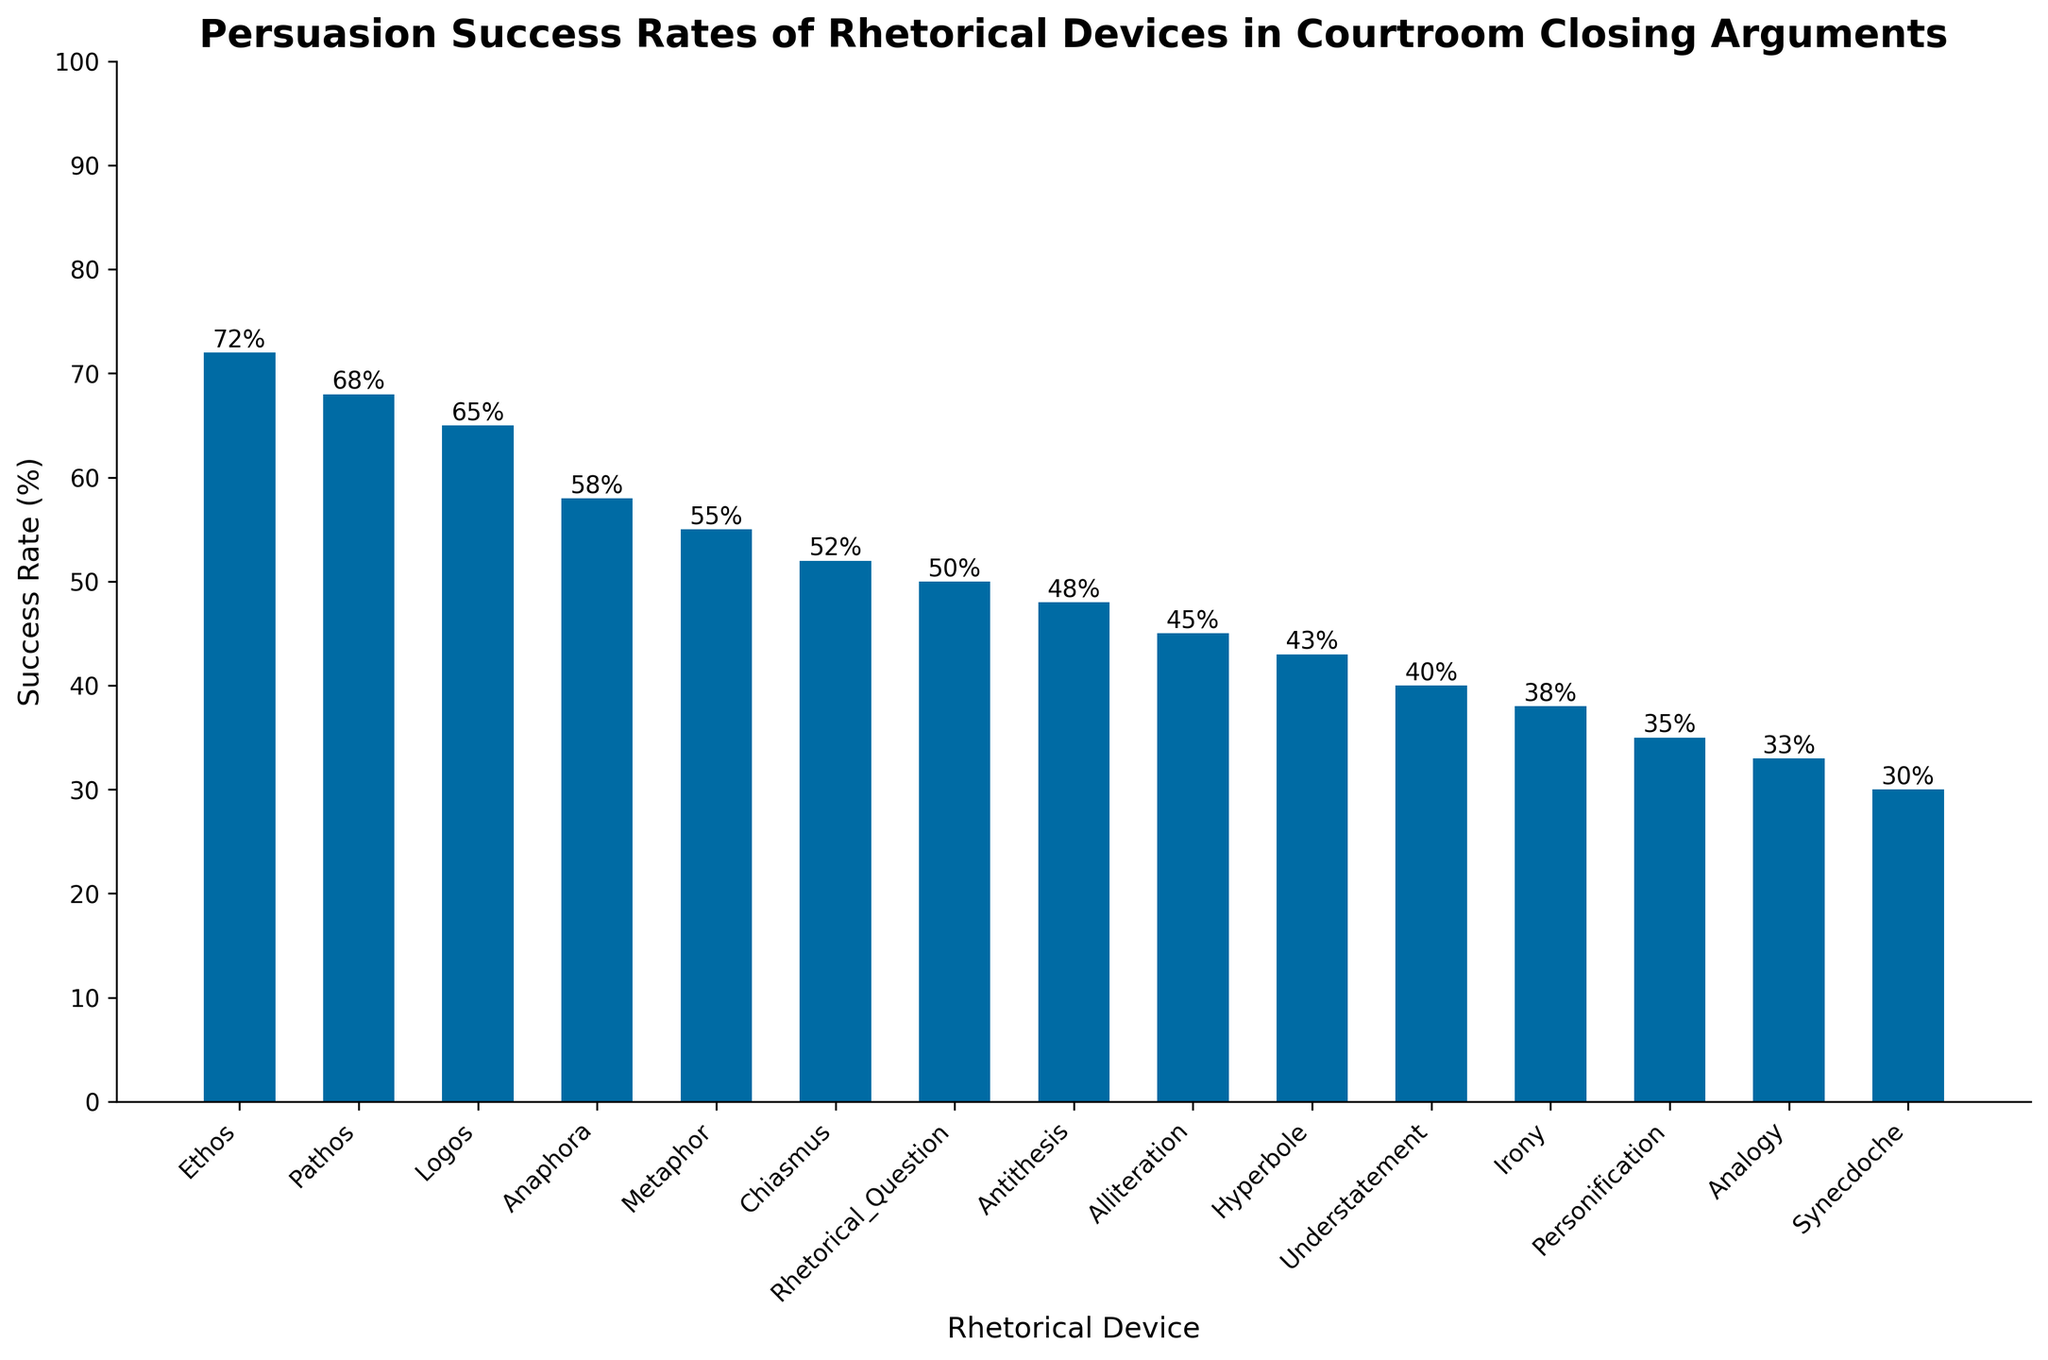which rhetorical device has the highest persuasion success rate? By observing the heights of the bars in the bar chart, the bar representing the "Ethos" rhetorical device is the tallest, indicating it has the highest success rate among all listed devices.
Answer: Ethos Which rhetorical device has the lowest persuasion success rate? By comparing the heights of the bars, the bar representing "Synecdoche" is the shortest, indicating it has the lowest success rate among all listed devices.
Answer: Synecdoche What is the success rate for Pathos? By looking at the bar for Pathos and reading the value at the top of the bar, it shows a success rate of 68%.
Answer: 68% Which rhetorical device has a success rate of 50%? By examining the success rate values at the top of the bars, the bar for "Rhetorical Question" shows a success rate of 50%.
Answer: Rhetorical Question How much higher is the success rate of Metaphor compared to Irony? The success rate for Metaphor is 55%, and for Irony, it is 38%. Subtracting the Irony success rate from the Metaphor success rate gives 55% - 38% = 17%.
Answer: 17% What is the average success rate of Ethos, Pathos, and Logos? Add up the success rates of Ethos (72%), Pathos (68%), and Logos (65%) to get 205%, then divide by 3 to find the average: 205% / 3 = 68.33%.
Answer: 68.33% What is the range of success rates among all rhetorical devices? The highest success rate is 72% (Ethos), and the lowest is 30% (Synecdoche). The range is calculated by subtracting the lowest from the highest: 72% - 30% = 42%.
Answer: 42% How many rhetorical devices have a success rate above 50%? Count the bars that have a height corresponding to a success rate above 50%. These devices are Ethos, Pathos, Logos, Anaphora, Metaphor, and Chiasmus.
Answer: 6 What is the combined success rate of Alliteration and Hyperbole? Sum the success rates of Alliteration (45%) and Hyperbole (43%) to get the combined success rate: 45% + 43% = 88%.
Answer: 88% Which two rhetorical devices have the closest success rates? By examining the numerical values at the top of each bar, the success rates of "Rhetorical Question" (50%) and "Antithesis" (48%) are the closest to each other, with a difference of only 2%.
Answer: Rhetorical Question and Antithesis 